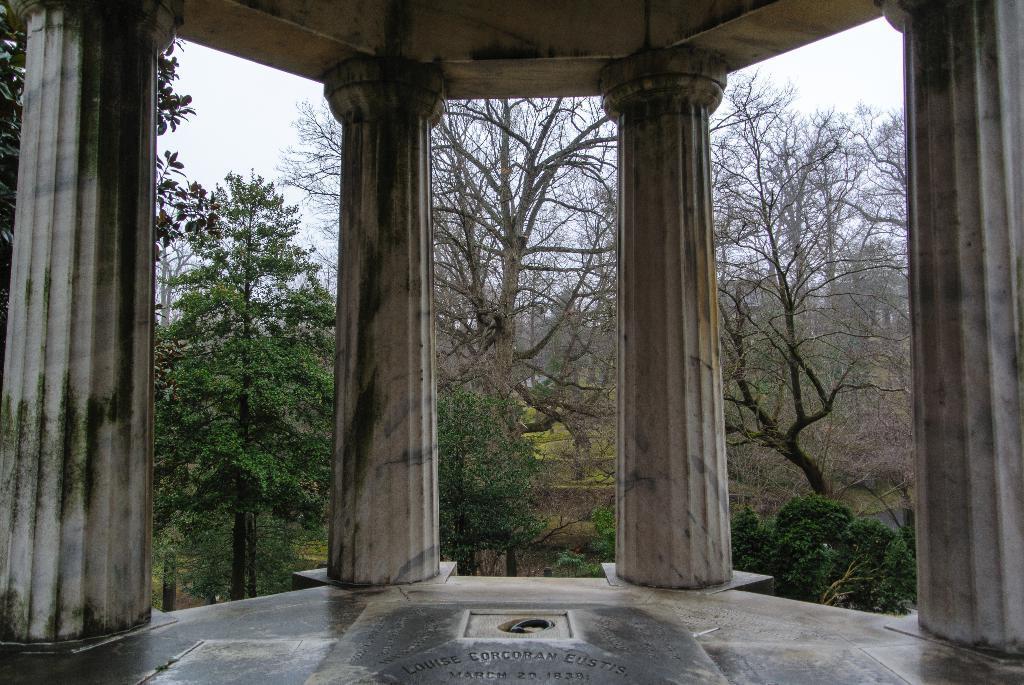Describe this image in one or two sentences. In the foreground of the picture there is a building and there are pillars. In the background there are trees. Sky is cloudy. 